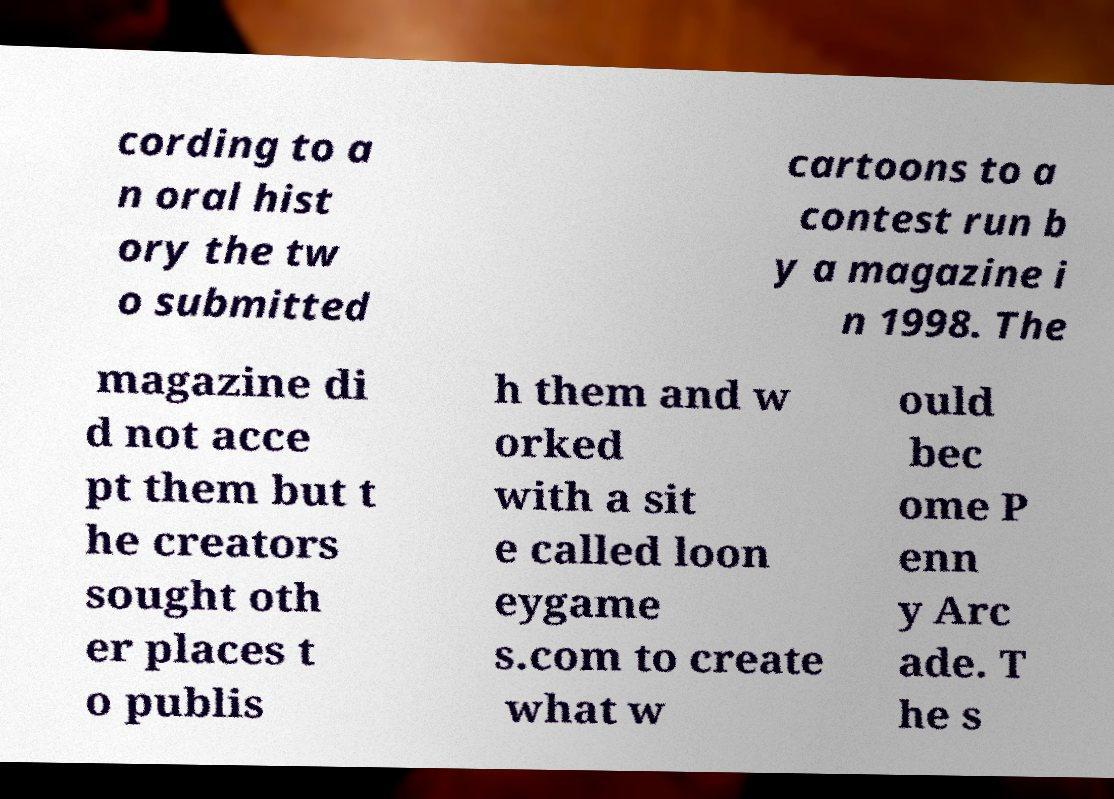Can you accurately transcribe the text from the provided image for me? cording to a n oral hist ory the tw o submitted cartoons to a contest run b y a magazine i n 1998. The magazine di d not acce pt them but t he creators sought oth er places t o publis h them and w orked with a sit e called loon eygame s.com to create what w ould bec ome P enn y Arc ade. T he s 